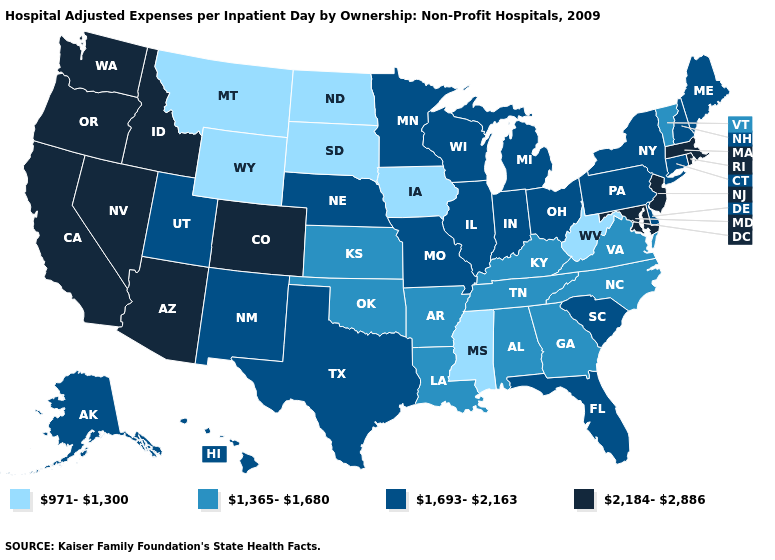What is the highest value in the USA?
Keep it brief. 2,184-2,886. What is the value of Illinois?
Concise answer only. 1,693-2,163. What is the lowest value in the Northeast?
Be succinct. 1,365-1,680. What is the value of Arizona?
Concise answer only. 2,184-2,886. Among the states that border Pennsylvania , which have the lowest value?
Give a very brief answer. West Virginia. Name the states that have a value in the range 1,365-1,680?
Write a very short answer. Alabama, Arkansas, Georgia, Kansas, Kentucky, Louisiana, North Carolina, Oklahoma, Tennessee, Vermont, Virginia. Does Minnesota have a lower value than Missouri?
Concise answer only. No. What is the lowest value in the USA?
Give a very brief answer. 971-1,300. Among the states that border Utah , which have the lowest value?
Short answer required. Wyoming. Name the states that have a value in the range 971-1,300?
Concise answer only. Iowa, Mississippi, Montana, North Dakota, South Dakota, West Virginia, Wyoming. What is the lowest value in the USA?
Write a very short answer. 971-1,300. Does Louisiana have the lowest value in the USA?
Write a very short answer. No. What is the lowest value in the USA?
Quick response, please. 971-1,300. Which states hav the highest value in the West?
Answer briefly. Arizona, California, Colorado, Idaho, Nevada, Oregon, Washington. What is the value of Kentucky?
Be succinct. 1,365-1,680. 